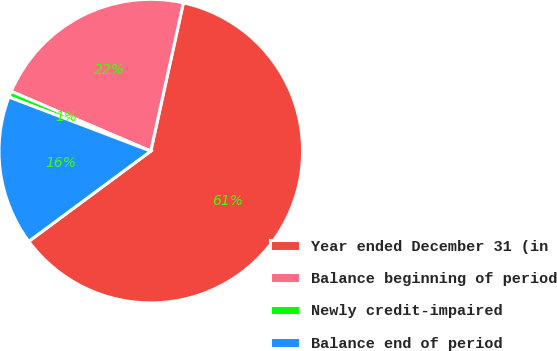<chart> <loc_0><loc_0><loc_500><loc_500><pie_chart><fcel>Year ended December 31 (in<fcel>Balance beginning of period<fcel>Newly credit-impaired<fcel>Balance end of period<nl><fcel>61.41%<fcel>22.01%<fcel>0.64%<fcel>15.93%<nl></chart> 